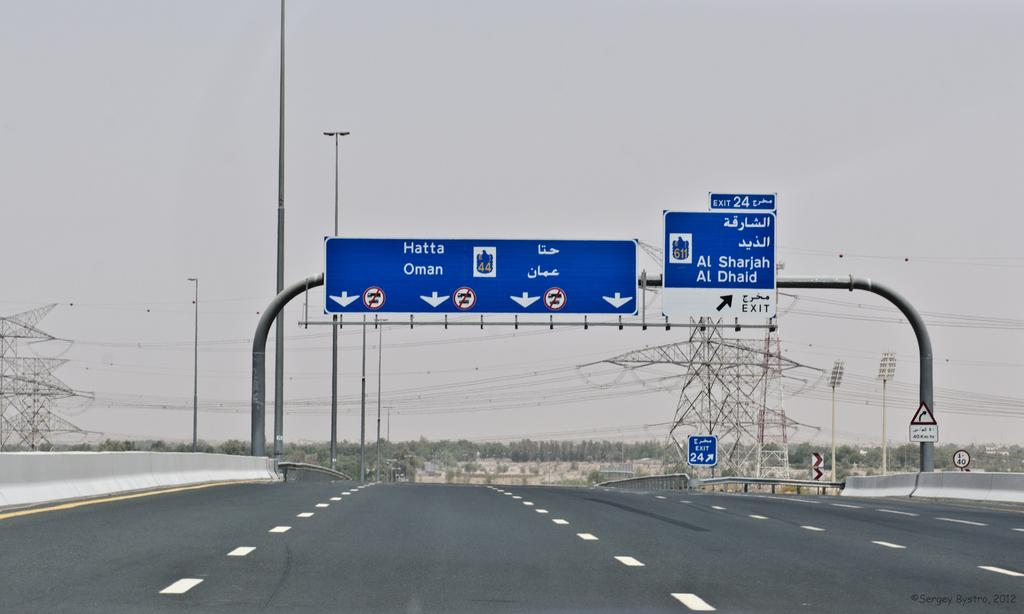<image>
Share a concise interpretation of the image provided. A blue freeway street sign that says Al Sharjah 